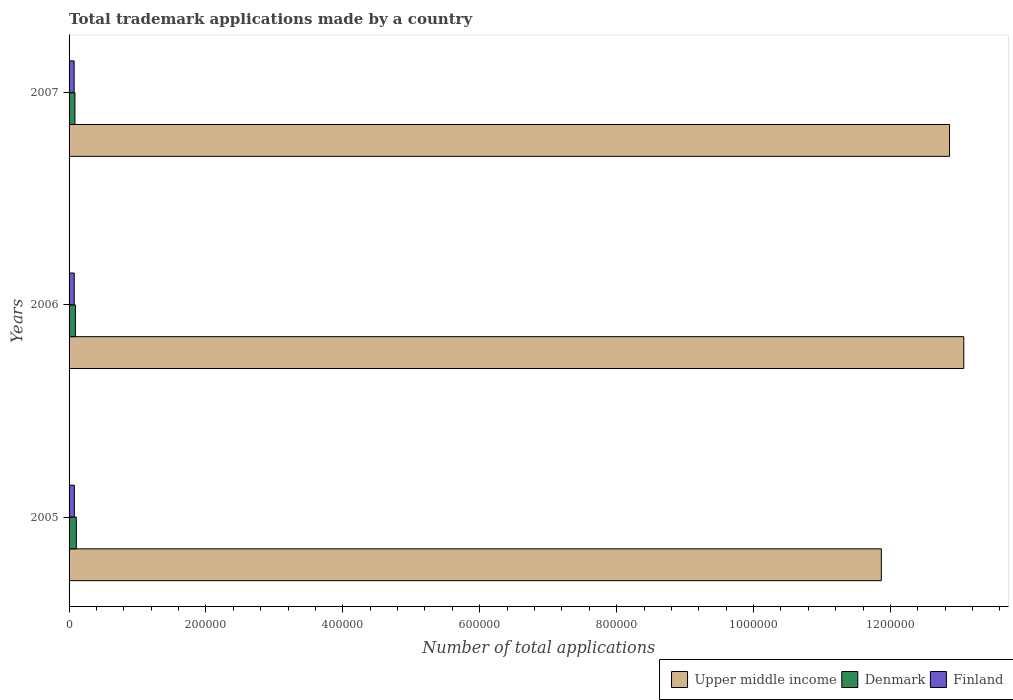How many groups of bars are there?
Keep it short and to the point. 3. Are the number of bars per tick equal to the number of legend labels?
Offer a terse response. Yes. What is the label of the 3rd group of bars from the top?
Your response must be concise. 2005. What is the number of applications made by in Finland in 2006?
Provide a short and direct response. 7533. Across all years, what is the maximum number of applications made by in Upper middle income?
Keep it short and to the point. 1.31e+06. Across all years, what is the minimum number of applications made by in Finland?
Your answer should be compact. 7400. In which year was the number of applications made by in Denmark minimum?
Offer a terse response. 2007. What is the total number of applications made by in Finland in the graph?
Make the answer very short. 2.27e+04. What is the difference between the number of applications made by in Upper middle income in 2005 and that in 2006?
Ensure brevity in your answer.  -1.20e+05. What is the difference between the number of applications made by in Finland in 2006 and the number of applications made by in Denmark in 2005?
Offer a very short reply. -3067. What is the average number of applications made by in Upper middle income per year?
Your answer should be compact. 1.26e+06. In the year 2005, what is the difference between the number of applications made by in Finland and number of applications made by in Denmark?
Make the answer very short. -2864. What is the ratio of the number of applications made by in Finland in 2006 to that in 2007?
Provide a short and direct response. 1.02. Is the difference between the number of applications made by in Finland in 2006 and 2007 greater than the difference between the number of applications made by in Denmark in 2006 and 2007?
Make the answer very short. No. What is the difference between the highest and the second highest number of applications made by in Denmark?
Offer a terse response. 1374. What is the difference between the highest and the lowest number of applications made by in Finland?
Provide a short and direct response. 336. In how many years, is the number of applications made by in Finland greater than the average number of applications made by in Finland taken over all years?
Provide a succinct answer. 1. Is the sum of the number of applications made by in Upper middle income in 2006 and 2007 greater than the maximum number of applications made by in Denmark across all years?
Offer a terse response. Yes. What does the 2nd bar from the top in 2006 represents?
Offer a terse response. Denmark. What does the 3rd bar from the bottom in 2006 represents?
Give a very brief answer. Finland. Are all the bars in the graph horizontal?
Make the answer very short. Yes. How many years are there in the graph?
Give a very brief answer. 3. Does the graph contain grids?
Keep it short and to the point. No. How many legend labels are there?
Provide a short and direct response. 3. What is the title of the graph?
Make the answer very short. Total trademark applications made by a country. What is the label or title of the X-axis?
Your answer should be very brief. Number of total applications. What is the label or title of the Y-axis?
Your answer should be very brief. Years. What is the Number of total applications in Upper middle income in 2005?
Keep it short and to the point. 1.19e+06. What is the Number of total applications of Denmark in 2005?
Provide a succinct answer. 1.06e+04. What is the Number of total applications in Finland in 2005?
Give a very brief answer. 7736. What is the Number of total applications of Upper middle income in 2006?
Give a very brief answer. 1.31e+06. What is the Number of total applications of Denmark in 2006?
Provide a short and direct response. 9226. What is the Number of total applications of Finland in 2006?
Provide a short and direct response. 7533. What is the Number of total applications of Upper middle income in 2007?
Provide a short and direct response. 1.29e+06. What is the Number of total applications in Denmark in 2007?
Offer a terse response. 8583. What is the Number of total applications in Finland in 2007?
Ensure brevity in your answer.  7400. Across all years, what is the maximum Number of total applications of Upper middle income?
Keep it short and to the point. 1.31e+06. Across all years, what is the maximum Number of total applications of Denmark?
Provide a short and direct response. 1.06e+04. Across all years, what is the maximum Number of total applications of Finland?
Your response must be concise. 7736. Across all years, what is the minimum Number of total applications in Upper middle income?
Your answer should be compact. 1.19e+06. Across all years, what is the minimum Number of total applications in Denmark?
Your answer should be very brief. 8583. Across all years, what is the minimum Number of total applications of Finland?
Offer a terse response. 7400. What is the total Number of total applications of Upper middle income in the graph?
Provide a succinct answer. 3.78e+06. What is the total Number of total applications in Denmark in the graph?
Keep it short and to the point. 2.84e+04. What is the total Number of total applications of Finland in the graph?
Your answer should be very brief. 2.27e+04. What is the difference between the Number of total applications of Upper middle income in 2005 and that in 2006?
Offer a terse response. -1.20e+05. What is the difference between the Number of total applications in Denmark in 2005 and that in 2006?
Keep it short and to the point. 1374. What is the difference between the Number of total applications in Finland in 2005 and that in 2006?
Make the answer very short. 203. What is the difference between the Number of total applications in Upper middle income in 2005 and that in 2007?
Give a very brief answer. -9.96e+04. What is the difference between the Number of total applications in Denmark in 2005 and that in 2007?
Offer a terse response. 2017. What is the difference between the Number of total applications in Finland in 2005 and that in 2007?
Provide a short and direct response. 336. What is the difference between the Number of total applications of Upper middle income in 2006 and that in 2007?
Make the answer very short. 2.08e+04. What is the difference between the Number of total applications in Denmark in 2006 and that in 2007?
Make the answer very short. 643. What is the difference between the Number of total applications of Finland in 2006 and that in 2007?
Keep it short and to the point. 133. What is the difference between the Number of total applications of Upper middle income in 2005 and the Number of total applications of Denmark in 2006?
Keep it short and to the point. 1.18e+06. What is the difference between the Number of total applications of Upper middle income in 2005 and the Number of total applications of Finland in 2006?
Keep it short and to the point. 1.18e+06. What is the difference between the Number of total applications in Denmark in 2005 and the Number of total applications in Finland in 2006?
Provide a short and direct response. 3067. What is the difference between the Number of total applications in Upper middle income in 2005 and the Number of total applications in Denmark in 2007?
Keep it short and to the point. 1.18e+06. What is the difference between the Number of total applications of Upper middle income in 2005 and the Number of total applications of Finland in 2007?
Your answer should be compact. 1.18e+06. What is the difference between the Number of total applications of Denmark in 2005 and the Number of total applications of Finland in 2007?
Offer a very short reply. 3200. What is the difference between the Number of total applications in Upper middle income in 2006 and the Number of total applications in Denmark in 2007?
Offer a very short reply. 1.30e+06. What is the difference between the Number of total applications of Upper middle income in 2006 and the Number of total applications of Finland in 2007?
Give a very brief answer. 1.30e+06. What is the difference between the Number of total applications in Denmark in 2006 and the Number of total applications in Finland in 2007?
Give a very brief answer. 1826. What is the average Number of total applications of Upper middle income per year?
Provide a short and direct response. 1.26e+06. What is the average Number of total applications in Denmark per year?
Your answer should be very brief. 9469.67. What is the average Number of total applications in Finland per year?
Offer a terse response. 7556.33. In the year 2005, what is the difference between the Number of total applications in Upper middle income and Number of total applications in Denmark?
Your answer should be very brief. 1.18e+06. In the year 2005, what is the difference between the Number of total applications in Upper middle income and Number of total applications in Finland?
Offer a very short reply. 1.18e+06. In the year 2005, what is the difference between the Number of total applications of Denmark and Number of total applications of Finland?
Ensure brevity in your answer.  2864. In the year 2006, what is the difference between the Number of total applications of Upper middle income and Number of total applications of Denmark?
Your answer should be compact. 1.30e+06. In the year 2006, what is the difference between the Number of total applications in Upper middle income and Number of total applications in Finland?
Provide a short and direct response. 1.30e+06. In the year 2006, what is the difference between the Number of total applications of Denmark and Number of total applications of Finland?
Offer a terse response. 1693. In the year 2007, what is the difference between the Number of total applications of Upper middle income and Number of total applications of Denmark?
Keep it short and to the point. 1.28e+06. In the year 2007, what is the difference between the Number of total applications in Upper middle income and Number of total applications in Finland?
Make the answer very short. 1.28e+06. In the year 2007, what is the difference between the Number of total applications of Denmark and Number of total applications of Finland?
Offer a very short reply. 1183. What is the ratio of the Number of total applications in Upper middle income in 2005 to that in 2006?
Your answer should be very brief. 0.91. What is the ratio of the Number of total applications in Denmark in 2005 to that in 2006?
Your response must be concise. 1.15. What is the ratio of the Number of total applications of Finland in 2005 to that in 2006?
Offer a very short reply. 1.03. What is the ratio of the Number of total applications of Upper middle income in 2005 to that in 2007?
Give a very brief answer. 0.92. What is the ratio of the Number of total applications in Denmark in 2005 to that in 2007?
Make the answer very short. 1.24. What is the ratio of the Number of total applications of Finland in 2005 to that in 2007?
Offer a terse response. 1.05. What is the ratio of the Number of total applications of Upper middle income in 2006 to that in 2007?
Offer a very short reply. 1.02. What is the ratio of the Number of total applications in Denmark in 2006 to that in 2007?
Your response must be concise. 1.07. What is the difference between the highest and the second highest Number of total applications of Upper middle income?
Your answer should be compact. 2.08e+04. What is the difference between the highest and the second highest Number of total applications of Denmark?
Offer a very short reply. 1374. What is the difference between the highest and the second highest Number of total applications in Finland?
Ensure brevity in your answer.  203. What is the difference between the highest and the lowest Number of total applications in Upper middle income?
Ensure brevity in your answer.  1.20e+05. What is the difference between the highest and the lowest Number of total applications of Denmark?
Give a very brief answer. 2017. What is the difference between the highest and the lowest Number of total applications of Finland?
Offer a terse response. 336. 